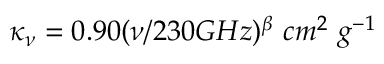Convert formula to latex. <formula><loc_0><loc_0><loc_500><loc_500>\kappa _ { \nu } = 0 . 9 0 ( \nu / 2 3 0 G H z ) ^ { \beta } \ c m ^ { 2 } \ g ^ { - 1 }</formula> 